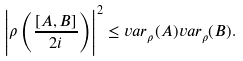<formula> <loc_0><loc_0><loc_500><loc_500>\left | \rho \left ( { \frac { [ A , B ] } { 2 i } } \right ) \right | ^ { 2 } \leq v a r _ { \rho } ( A ) v a r _ { \rho } ( B ) .</formula> 